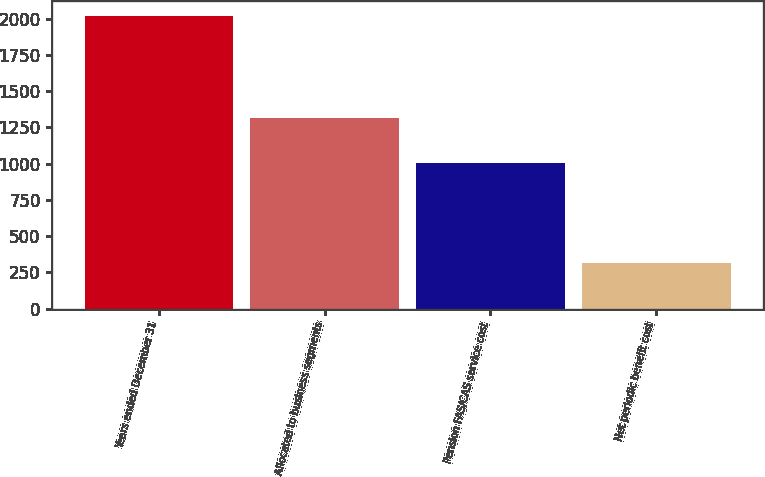Convert chart to OTSL. <chart><loc_0><loc_0><loc_500><loc_500><bar_chart><fcel>Years ended December 31<fcel>Allocated to business segments<fcel>Pension FAS/CAS service cost<fcel>Net periodic benefit cost<nl><fcel>2018<fcel>1318<fcel>1005<fcel>313<nl></chart> 